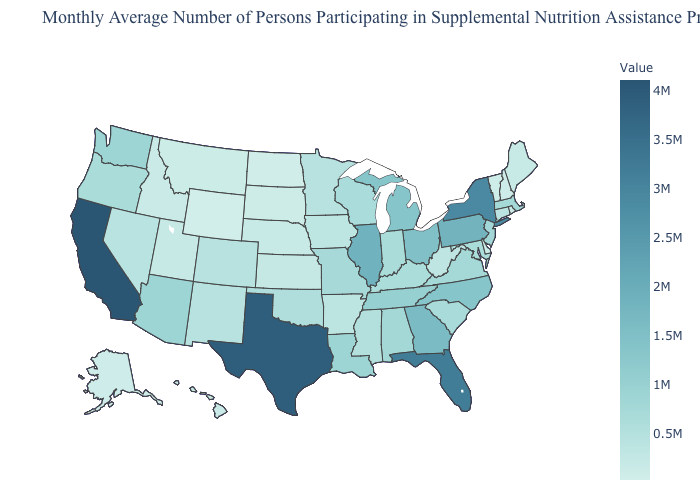Does Kansas have the highest value in the USA?
Give a very brief answer. No. Does the map have missing data?
Answer briefly. No. Does California have the highest value in the USA?
Answer briefly. Yes. Does the map have missing data?
Be succinct. No. Is the legend a continuous bar?
Short answer required. Yes. Among the states that border California , does Nevada have the lowest value?
Answer briefly. Yes. 